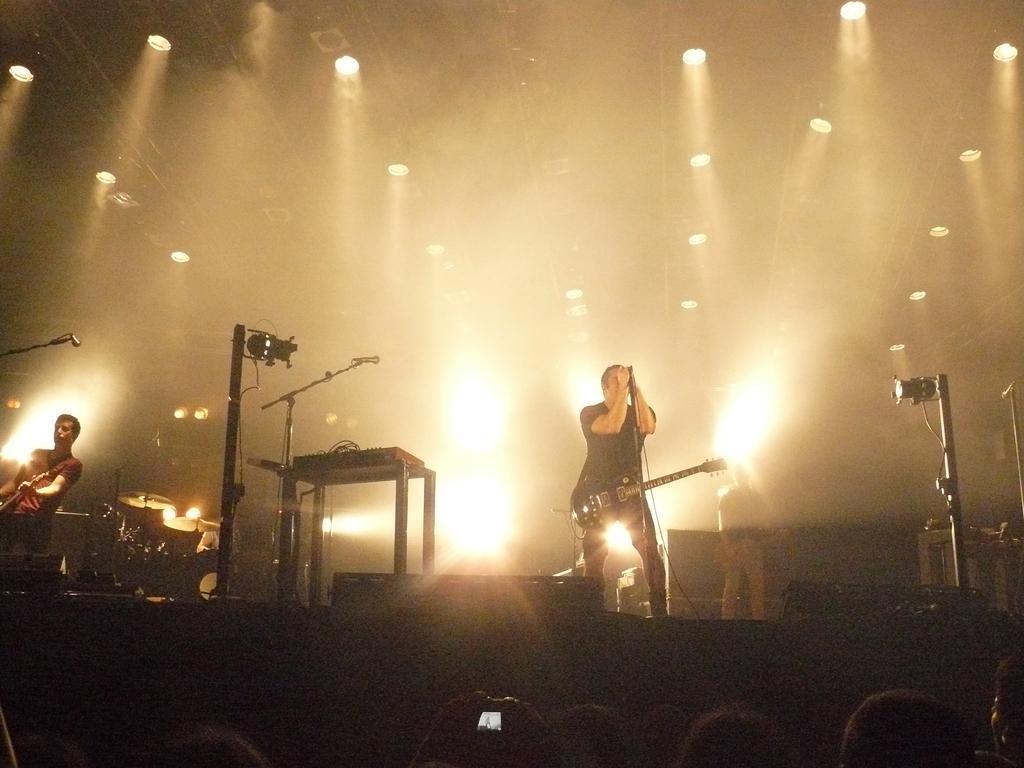Please provide a concise description of this image. In the image we can see there are people who are standing and holding a guitar in their hand. 